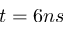<formula> <loc_0><loc_0><loc_500><loc_500>t = 6 n s</formula> 